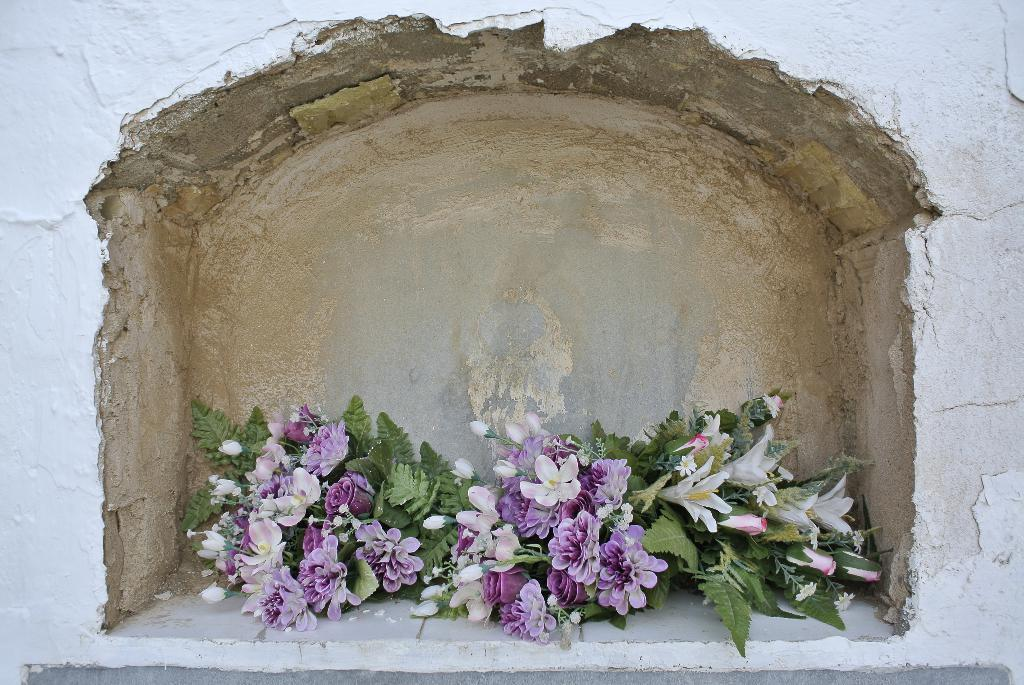What is present on the wall in the image? There is a shelf on the wall in the image. What can be found on the shelf? There are flower vases on the shelf. What type of insurance policy is being discussed in the image? There is no discussion of insurance policies in the image; it features a wall with a shelf and flower vases. 